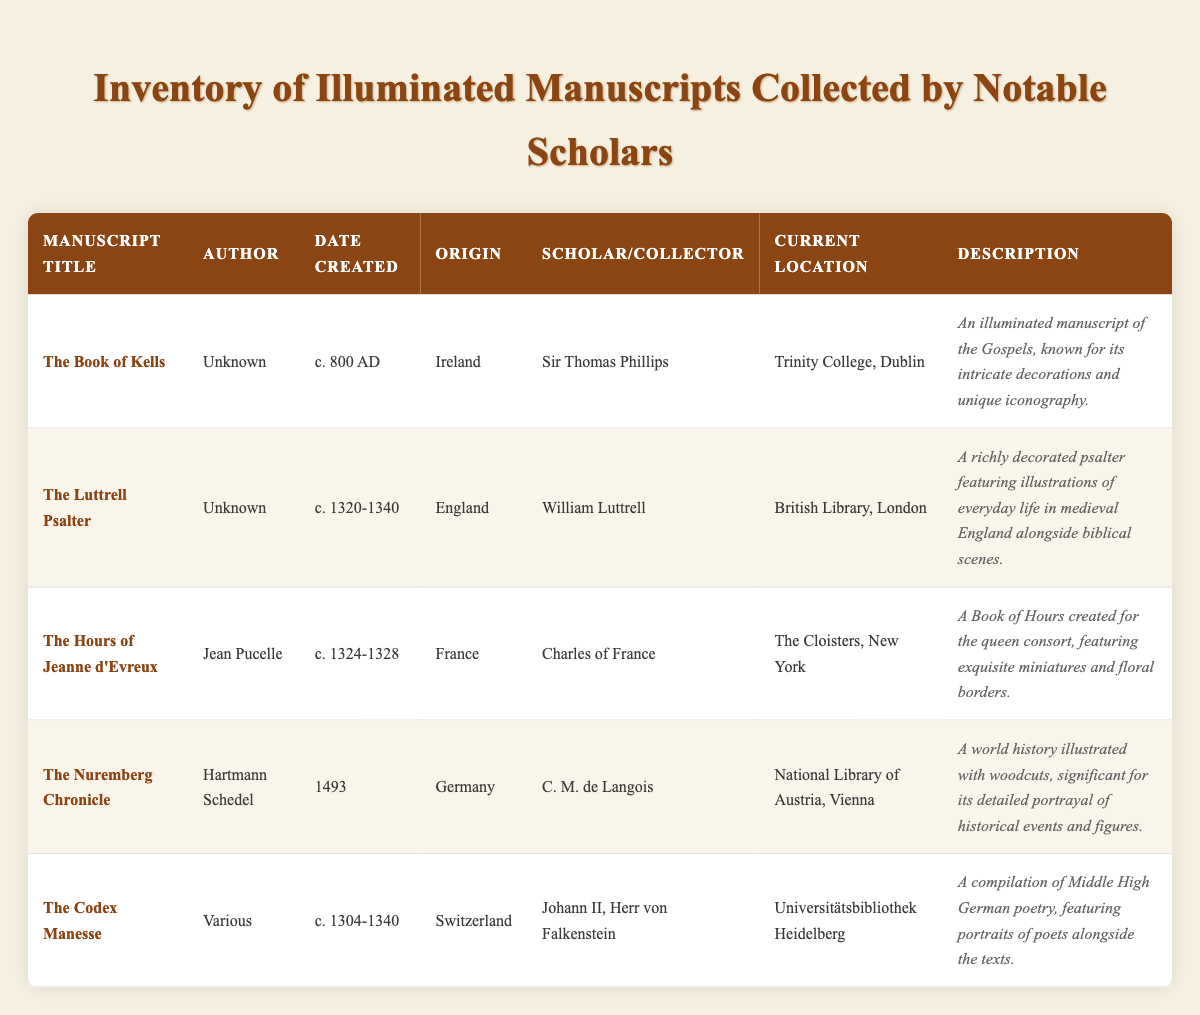What is the origin of "The Book of Kells"? The table lists "The Book of Kells" and shows its origin as "Ireland" in the corresponding row.
Answer: Ireland Who was the scholar collector of "The Luttrell Psalter"? Looking at the row for "The Luttrell Psalter", the scholar collector is noted as "William Luttrell".
Answer: William Luttrell Is "The Nuremberg Chronicle" an illuminated manuscript? The table does not explicitly define what constitutes an illuminated manuscript but given the description of "The Nuremberg Chronicle" as "A world history illustrated with woodcuts", we can infer it contains illustrations, which are often a characteristic of illuminated manuscripts. Thus, the answer is yes.
Answer: Yes How many manuscripts were collected by scholars from Germany? From the table, "The Nuremberg Chronicle" is the only manuscript listed with an origin in Germany. Therefore, there is one manuscript from Germany.
Answer: 1 Which manuscript was created for a queen consort? Referring to the row for "The Hours of Jeanne d'Evreux," it is noted that this manuscript was created for the queen consort, indicating its significance in that context.
Answer: The Hours of Jeanne d'Evreux What is the average date range for the manuscripts listed? To find the average date range, we note the dates: c. 800 AD (1), c. 1320-1340 (2), c. 1324-1328 (3), 1493 (4), c. 1304-1340 (5). The earliest is around 800 AD and the latest is 1493, leading to a rough average of the centuries: roughly 800 to 1490s. This is approximated around the 13th century.
Answer: 13th century Who is the author of "The Codex Manesse"? The table indicates "The Codex Manesse" was authored by "Various". This indicates multiple contributors rather than a single author.
Answer: Various Which manuscript currently resides in the British Library, London? By examining the table, the manuscript listed as residing in the British Library, London, is "The Luttrell Psalter".
Answer: The Luttrell Psalter What are the current locations of the manuscripts created between 1300 and 1400? From the table, the manuscripts created within this range are "The Luttrell Psalter" (British Library, London), "The Hours of Jeanne d'Evreux" (The Cloisters, New York), and "The Codex Manesse" (Universitätsbibliothek Heidelberg). Thus, their current locations are as follows: British Library, London; The Cloisters, New York; and Universitätsbibliothek Heidelberg.
Answer: British Library, London; The Cloisters, New York; Universitätsbibliothek Heidelberg 